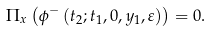<formula> <loc_0><loc_0><loc_500><loc_500>\Pi _ { x } \left ( \phi ^ { - } \left ( t _ { 2 } ; t _ { 1 } , 0 , y _ { 1 } , \varepsilon \right ) \right ) = 0 .</formula> 